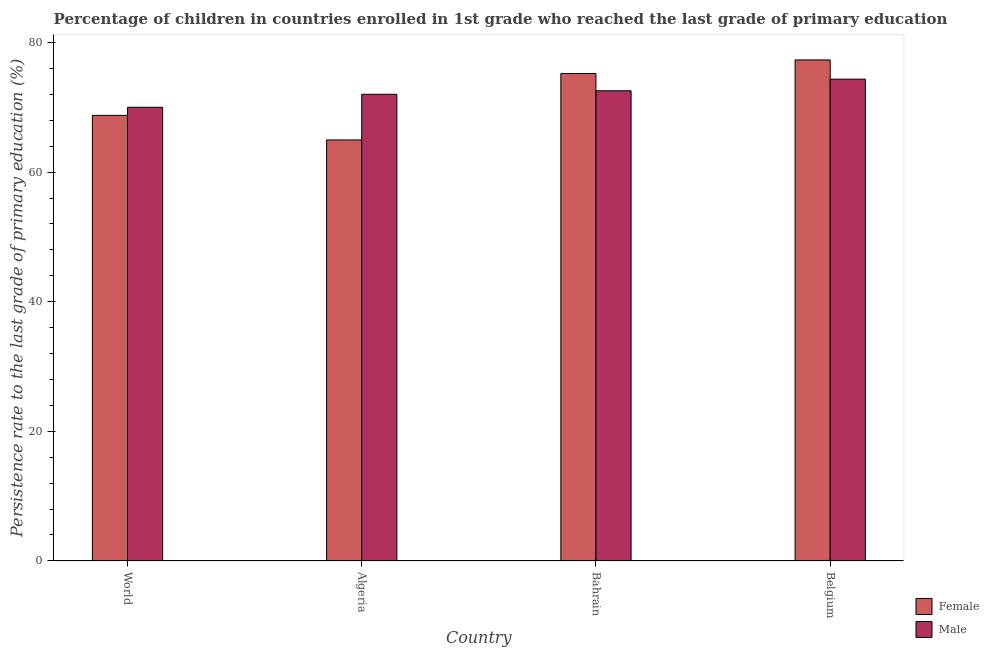How many groups of bars are there?
Offer a terse response. 4. Are the number of bars per tick equal to the number of legend labels?
Give a very brief answer. Yes. Are the number of bars on each tick of the X-axis equal?
Your answer should be compact. Yes. In how many cases, is the number of bars for a given country not equal to the number of legend labels?
Ensure brevity in your answer.  0. What is the persistence rate of male students in Bahrain?
Offer a very short reply. 72.55. Across all countries, what is the maximum persistence rate of male students?
Offer a very short reply. 74.35. Across all countries, what is the minimum persistence rate of female students?
Make the answer very short. 64.97. In which country was the persistence rate of male students maximum?
Provide a short and direct response. Belgium. What is the total persistence rate of female students in the graph?
Provide a short and direct response. 286.26. What is the difference between the persistence rate of female students in Algeria and that in Bahrain?
Offer a terse response. -10.25. What is the difference between the persistence rate of male students in Algeria and the persistence rate of female students in World?
Your response must be concise. 3.25. What is the average persistence rate of female students per country?
Provide a succinct answer. 71.57. What is the difference between the persistence rate of female students and persistence rate of male students in World?
Your response must be concise. -1.25. In how many countries, is the persistence rate of female students greater than 28 %?
Offer a very short reply. 4. What is the ratio of the persistence rate of male students in Algeria to that in Bahrain?
Provide a short and direct response. 0.99. What is the difference between the highest and the second highest persistence rate of male students?
Your response must be concise. 1.8. What is the difference between the highest and the lowest persistence rate of female students?
Keep it short and to the point. 12.35. In how many countries, is the persistence rate of female students greater than the average persistence rate of female students taken over all countries?
Offer a terse response. 2. Is the sum of the persistence rate of male students in Algeria and Bahrain greater than the maximum persistence rate of female students across all countries?
Make the answer very short. Yes. What does the 2nd bar from the right in Algeria represents?
Offer a terse response. Female. What is the difference between two consecutive major ticks on the Y-axis?
Your answer should be very brief. 20. Does the graph contain any zero values?
Offer a very short reply. No. Does the graph contain grids?
Give a very brief answer. No. How are the legend labels stacked?
Provide a short and direct response. Vertical. What is the title of the graph?
Your answer should be very brief. Percentage of children in countries enrolled in 1st grade who reached the last grade of primary education. What is the label or title of the Y-axis?
Your answer should be compact. Persistence rate to the last grade of primary education (%). What is the Persistence rate to the last grade of primary education (%) of Female in World?
Offer a terse response. 68.76. What is the Persistence rate to the last grade of primary education (%) in Male in World?
Make the answer very short. 70.01. What is the Persistence rate to the last grade of primary education (%) in Female in Algeria?
Provide a succinct answer. 64.97. What is the Persistence rate to the last grade of primary education (%) in Male in Algeria?
Give a very brief answer. 72.01. What is the Persistence rate to the last grade of primary education (%) of Female in Bahrain?
Make the answer very short. 75.22. What is the Persistence rate to the last grade of primary education (%) in Male in Bahrain?
Provide a succinct answer. 72.55. What is the Persistence rate to the last grade of primary education (%) of Female in Belgium?
Offer a very short reply. 77.32. What is the Persistence rate to the last grade of primary education (%) of Male in Belgium?
Provide a short and direct response. 74.35. Across all countries, what is the maximum Persistence rate to the last grade of primary education (%) in Female?
Make the answer very short. 77.32. Across all countries, what is the maximum Persistence rate to the last grade of primary education (%) in Male?
Make the answer very short. 74.35. Across all countries, what is the minimum Persistence rate to the last grade of primary education (%) in Female?
Your response must be concise. 64.97. Across all countries, what is the minimum Persistence rate to the last grade of primary education (%) of Male?
Offer a terse response. 70.01. What is the total Persistence rate to the last grade of primary education (%) in Female in the graph?
Ensure brevity in your answer.  286.26. What is the total Persistence rate to the last grade of primary education (%) of Male in the graph?
Ensure brevity in your answer.  288.93. What is the difference between the Persistence rate to the last grade of primary education (%) in Female in World and that in Algeria?
Offer a terse response. 3.79. What is the difference between the Persistence rate to the last grade of primary education (%) in Male in World and that in Algeria?
Your answer should be compact. -2. What is the difference between the Persistence rate to the last grade of primary education (%) in Female in World and that in Bahrain?
Your response must be concise. -6.46. What is the difference between the Persistence rate to the last grade of primary education (%) in Male in World and that in Bahrain?
Provide a short and direct response. -2.54. What is the difference between the Persistence rate to the last grade of primary education (%) of Female in World and that in Belgium?
Provide a short and direct response. -8.56. What is the difference between the Persistence rate to the last grade of primary education (%) of Male in World and that in Belgium?
Offer a terse response. -4.34. What is the difference between the Persistence rate to the last grade of primary education (%) in Female in Algeria and that in Bahrain?
Provide a succinct answer. -10.25. What is the difference between the Persistence rate to the last grade of primary education (%) of Male in Algeria and that in Bahrain?
Your answer should be compact. -0.54. What is the difference between the Persistence rate to the last grade of primary education (%) in Female in Algeria and that in Belgium?
Provide a short and direct response. -12.35. What is the difference between the Persistence rate to the last grade of primary education (%) in Male in Algeria and that in Belgium?
Your response must be concise. -2.34. What is the difference between the Persistence rate to the last grade of primary education (%) of Female in Bahrain and that in Belgium?
Your response must be concise. -2.1. What is the difference between the Persistence rate to the last grade of primary education (%) in Male in Bahrain and that in Belgium?
Offer a very short reply. -1.8. What is the difference between the Persistence rate to the last grade of primary education (%) in Female in World and the Persistence rate to the last grade of primary education (%) in Male in Algeria?
Offer a very short reply. -3.25. What is the difference between the Persistence rate to the last grade of primary education (%) of Female in World and the Persistence rate to the last grade of primary education (%) of Male in Bahrain?
Your answer should be compact. -3.79. What is the difference between the Persistence rate to the last grade of primary education (%) of Female in World and the Persistence rate to the last grade of primary education (%) of Male in Belgium?
Make the answer very short. -5.59. What is the difference between the Persistence rate to the last grade of primary education (%) of Female in Algeria and the Persistence rate to the last grade of primary education (%) of Male in Bahrain?
Your answer should be very brief. -7.59. What is the difference between the Persistence rate to the last grade of primary education (%) of Female in Algeria and the Persistence rate to the last grade of primary education (%) of Male in Belgium?
Ensure brevity in your answer.  -9.38. What is the difference between the Persistence rate to the last grade of primary education (%) of Female in Bahrain and the Persistence rate to the last grade of primary education (%) of Male in Belgium?
Your answer should be very brief. 0.87. What is the average Persistence rate to the last grade of primary education (%) in Female per country?
Offer a terse response. 71.57. What is the average Persistence rate to the last grade of primary education (%) of Male per country?
Give a very brief answer. 72.23. What is the difference between the Persistence rate to the last grade of primary education (%) of Female and Persistence rate to the last grade of primary education (%) of Male in World?
Give a very brief answer. -1.25. What is the difference between the Persistence rate to the last grade of primary education (%) in Female and Persistence rate to the last grade of primary education (%) in Male in Algeria?
Give a very brief answer. -7.05. What is the difference between the Persistence rate to the last grade of primary education (%) of Female and Persistence rate to the last grade of primary education (%) of Male in Bahrain?
Offer a terse response. 2.66. What is the difference between the Persistence rate to the last grade of primary education (%) of Female and Persistence rate to the last grade of primary education (%) of Male in Belgium?
Your answer should be very brief. 2.97. What is the ratio of the Persistence rate to the last grade of primary education (%) of Female in World to that in Algeria?
Make the answer very short. 1.06. What is the ratio of the Persistence rate to the last grade of primary education (%) of Male in World to that in Algeria?
Provide a short and direct response. 0.97. What is the ratio of the Persistence rate to the last grade of primary education (%) of Female in World to that in Bahrain?
Make the answer very short. 0.91. What is the ratio of the Persistence rate to the last grade of primary education (%) of Male in World to that in Bahrain?
Give a very brief answer. 0.96. What is the ratio of the Persistence rate to the last grade of primary education (%) of Female in World to that in Belgium?
Your answer should be compact. 0.89. What is the ratio of the Persistence rate to the last grade of primary education (%) of Male in World to that in Belgium?
Provide a succinct answer. 0.94. What is the ratio of the Persistence rate to the last grade of primary education (%) in Female in Algeria to that in Bahrain?
Offer a very short reply. 0.86. What is the ratio of the Persistence rate to the last grade of primary education (%) of Male in Algeria to that in Bahrain?
Ensure brevity in your answer.  0.99. What is the ratio of the Persistence rate to the last grade of primary education (%) of Female in Algeria to that in Belgium?
Keep it short and to the point. 0.84. What is the ratio of the Persistence rate to the last grade of primary education (%) of Male in Algeria to that in Belgium?
Your response must be concise. 0.97. What is the ratio of the Persistence rate to the last grade of primary education (%) in Female in Bahrain to that in Belgium?
Make the answer very short. 0.97. What is the ratio of the Persistence rate to the last grade of primary education (%) of Male in Bahrain to that in Belgium?
Your answer should be very brief. 0.98. What is the difference between the highest and the second highest Persistence rate to the last grade of primary education (%) of Female?
Keep it short and to the point. 2.1. What is the difference between the highest and the second highest Persistence rate to the last grade of primary education (%) of Male?
Ensure brevity in your answer.  1.8. What is the difference between the highest and the lowest Persistence rate to the last grade of primary education (%) of Female?
Offer a terse response. 12.35. What is the difference between the highest and the lowest Persistence rate to the last grade of primary education (%) in Male?
Offer a terse response. 4.34. 